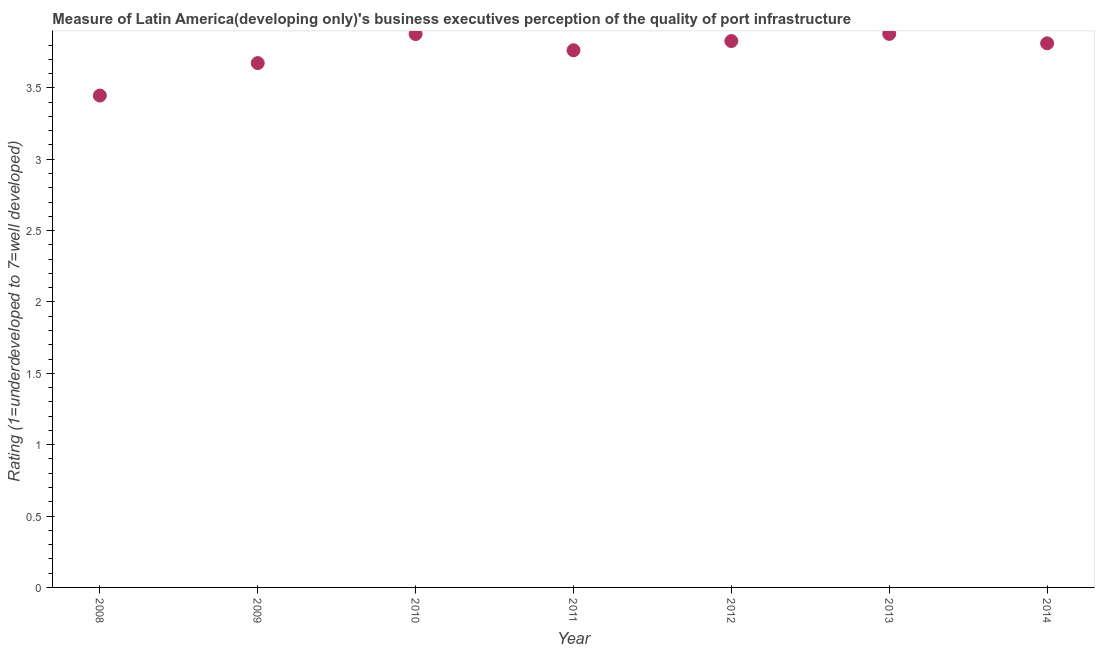What is the rating measuring quality of port infrastructure in 2014?
Offer a very short reply. 3.81. Across all years, what is the maximum rating measuring quality of port infrastructure?
Your answer should be very brief. 3.88. Across all years, what is the minimum rating measuring quality of port infrastructure?
Your answer should be very brief. 3.45. In which year was the rating measuring quality of port infrastructure maximum?
Offer a terse response. 2013. In which year was the rating measuring quality of port infrastructure minimum?
Keep it short and to the point. 2008. What is the sum of the rating measuring quality of port infrastructure?
Give a very brief answer. 26.28. What is the difference between the rating measuring quality of port infrastructure in 2010 and 2012?
Your response must be concise. 0.05. What is the average rating measuring quality of port infrastructure per year?
Provide a short and direct response. 3.75. What is the median rating measuring quality of port infrastructure?
Your answer should be compact. 3.81. What is the ratio of the rating measuring quality of port infrastructure in 2013 to that in 2014?
Make the answer very short. 1.02. Is the difference between the rating measuring quality of port infrastructure in 2010 and 2011 greater than the difference between any two years?
Offer a very short reply. No. What is the difference between the highest and the second highest rating measuring quality of port infrastructure?
Offer a very short reply. 0. Is the sum of the rating measuring quality of port infrastructure in 2008 and 2011 greater than the maximum rating measuring quality of port infrastructure across all years?
Provide a succinct answer. Yes. What is the difference between the highest and the lowest rating measuring quality of port infrastructure?
Keep it short and to the point. 0.43. How many dotlines are there?
Your answer should be compact. 1. What is the difference between two consecutive major ticks on the Y-axis?
Your answer should be compact. 0.5. What is the title of the graph?
Offer a terse response. Measure of Latin America(developing only)'s business executives perception of the quality of port infrastructure. What is the label or title of the X-axis?
Give a very brief answer. Year. What is the label or title of the Y-axis?
Your answer should be very brief. Rating (1=underdeveloped to 7=well developed) . What is the Rating (1=underdeveloped to 7=well developed)  in 2008?
Your answer should be very brief. 3.45. What is the Rating (1=underdeveloped to 7=well developed)  in 2009?
Offer a very short reply. 3.67. What is the Rating (1=underdeveloped to 7=well developed)  in 2010?
Give a very brief answer. 3.88. What is the Rating (1=underdeveloped to 7=well developed)  in 2011?
Give a very brief answer. 3.76. What is the Rating (1=underdeveloped to 7=well developed)  in 2012?
Offer a very short reply. 3.83. What is the Rating (1=underdeveloped to 7=well developed)  in 2013?
Your answer should be very brief. 3.88. What is the Rating (1=underdeveloped to 7=well developed)  in 2014?
Make the answer very short. 3.81. What is the difference between the Rating (1=underdeveloped to 7=well developed)  in 2008 and 2009?
Your answer should be very brief. -0.23. What is the difference between the Rating (1=underdeveloped to 7=well developed)  in 2008 and 2010?
Keep it short and to the point. -0.43. What is the difference between the Rating (1=underdeveloped to 7=well developed)  in 2008 and 2011?
Your response must be concise. -0.32. What is the difference between the Rating (1=underdeveloped to 7=well developed)  in 2008 and 2012?
Your answer should be compact. -0.38. What is the difference between the Rating (1=underdeveloped to 7=well developed)  in 2008 and 2013?
Your answer should be compact. -0.43. What is the difference between the Rating (1=underdeveloped to 7=well developed)  in 2008 and 2014?
Make the answer very short. -0.37. What is the difference between the Rating (1=underdeveloped to 7=well developed)  in 2009 and 2010?
Make the answer very short. -0.2. What is the difference between the Rating (1=underdeveloped to 7=well developed)  in 2009 and 2011?
Offer a terse response. -0.09. What is the difference between the Rating (1=underdeveloped to 7=well developed)  in 2009 and 2012?
Give a very brief answer. -0.15. What is the difference between the Rating (1=underdeveloped to 7=well developed)  in 2009 and 2013?
Your answer should be compact. -0.2. What is the difference between the Rating (1=underdeveloped to 7=well developed)  in 2009 and 2014?
Provide a short and direct response. -0.14. What is the difference between the Rating (1=underdeveloped to 7=well developed)  in 2010 and 2011?
Keep it short and to the point. 0.11. What is the difference between the Rating (1=underdeveloped to 7=well developed)  in 2010 and 2012?
Keep it short and to the point. 0.05. What is the difference between the Rating (1=underdeveloped to 7=well developed)  in 2010 and 2013?
Offer a terse response. -0. What is the difference between the Rating (1=underdeveloped to 7=well developed)  in 2010 and 2014?
Offer a terse response. 0.07. What is the difference between the Rating (1=underdeveloped to 7=well developed)  in 2011 and 2012?
Provide a short and direct response. -0.06. What is the difference between the Rating (1=underdeveloped to 7=well developed)  in 2011 and 2013?
Ensure brevity in your answer.  -0.11. What is the difference between the Rating (1=underdeveloped to 7=well developed)  in 2011 and 2014?
Make the answer very short. -0.05. What is the difference between the Rating (1=underdeveloped to 7=well developed)  in 2012 and 2013?
Offer a very short reply. -0.05. What is the difference between the Rating (1=underdeveloped to 7=well developed)  in 2012 and 2014?
Provide a succinct answer. 0.02. What is the difference between the Rating (1=underdeveloped to 7=well developed)  in 2013 and 2014?
Your answer should be compact. 0.07. What is the ratio of the Rating (1=underdeveloped to 7=well developed)  in 2008 to that in 2009?
Your response must be concise. 0.94. What is the ratio of the Rating (1=underdeveloped to 7=well developed)  in 2008 to that in 2010?
Your answer should be very brief. 0.89. What is the ratio of the Rating (1=underdeveloped to 7=well developed)  in 2008 to that in 2011?
Give a very brief answer. 0.92. What is the ratio of the Rating (1=underdeveloped to 7=well developed)  in 2008 to that in 2012?
Keep it short and to the point. 0.9. What is the ratio of the Rating (1=underdeveloped to 7=well developed)  in 2008 to that in 2013?
Offer a very short reply. 0.89. What is the ratio of the Rating (1=underdeveloped to 7=well developed)  in 2008 to that in 2014?
Your answer should be compact. 0.9. What is the ratio of the Rating (1=underdeveloped to 7=well developed)  in 2009 to that in 2010?
Provide a short and direct response. 0.95. What is the ratio of the Rating (1=underdeveloped to 7=well developed)  in 2009 to that in 2011?
Offer a terse response. 0.98. What is the ratio of the Rating (1=underdeveloped to 7=well developed)  in 2009 to that in 2013?
Provide a succinct answer. 0.95. What is the ratio of the Rating (1=underdeveloped to 7=well developed)  in 2009 to that in 2014?
Your response must be concise. 0.96. What is the ratio of the Rating (1=underdeveloped to 7=well developed)  in 2010 to that in 2011?
Your answer should be very brief. 1.03. What is the ratio of the Rating (1=underdeveloped to 7=well developed)  in 2010 to that in 2014?
Your answer should be compact. 1.02. What is the ratio of the Rating (1=underdeveloped to 7=well developed)  in 2011 to that in 2012?
Your response must be concise. 0.98. What is the ratio of the Rating (1=underdeveloped to 7=well developed)  in 2011 to that in 2013?
Your answer should be very brief. 0.97. What is the ratio of the Rating (1=underdeveloped to 7=well developed)  in 2012 to that in 2014?
Provide a short and direct response. 1. 